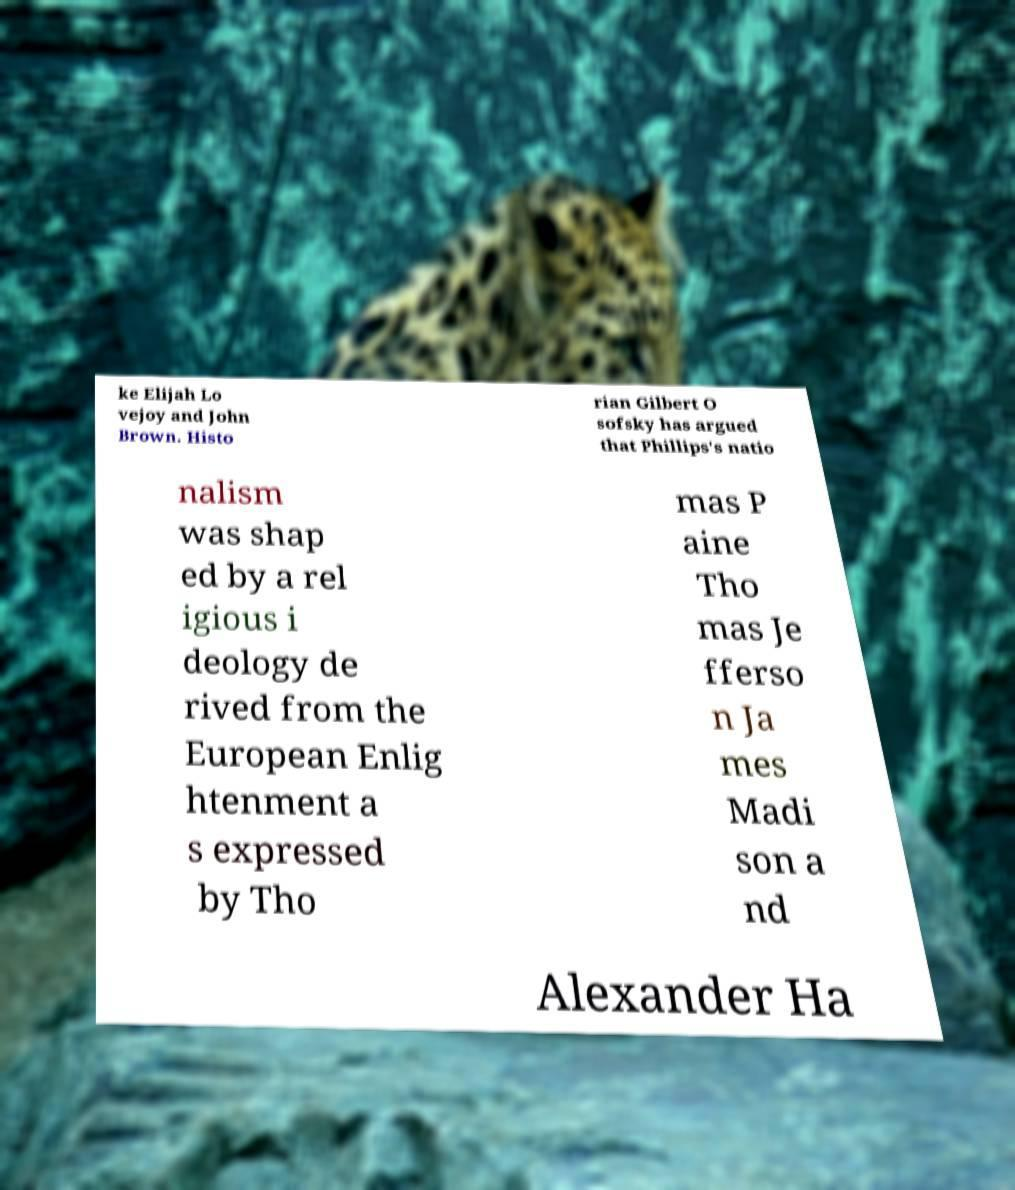I need the written content from this picture converted into text. Can you do that? ke Elijah Lo vejoy and John Brown. Histo rian Gilbert O sofsky has argued that Phillips's natio nalism was shap ed by a rel igious i deology de rived from the European Enlig htenment a s expressed by Tho mas P aine Tho mas Je fferso n Ja mes Madi son a nd Alexander Ha 